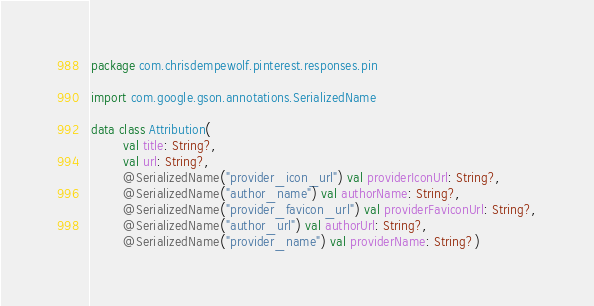<code> <loc_0><loc_0><loc_500><loc_500><_Kotlin_>package com.chrisdempewolf.pinterest.responses.pin

import com.google.gson.annotations.SerializedName

data class Attribution(
        val title: String?,
        val url: String?,
        @SerializedName("provider_icon_url") val providerIconUrl: String?,
        @SerializedName("author_name") val authorName: String?,
        @SerializedName("provider_favicon_url") val providerFaviconUrl: String?,
        @SerializedName("author_url") val authorUrl: String?,
        @SerializedName("provider_name") val providerName: String?)</code> 